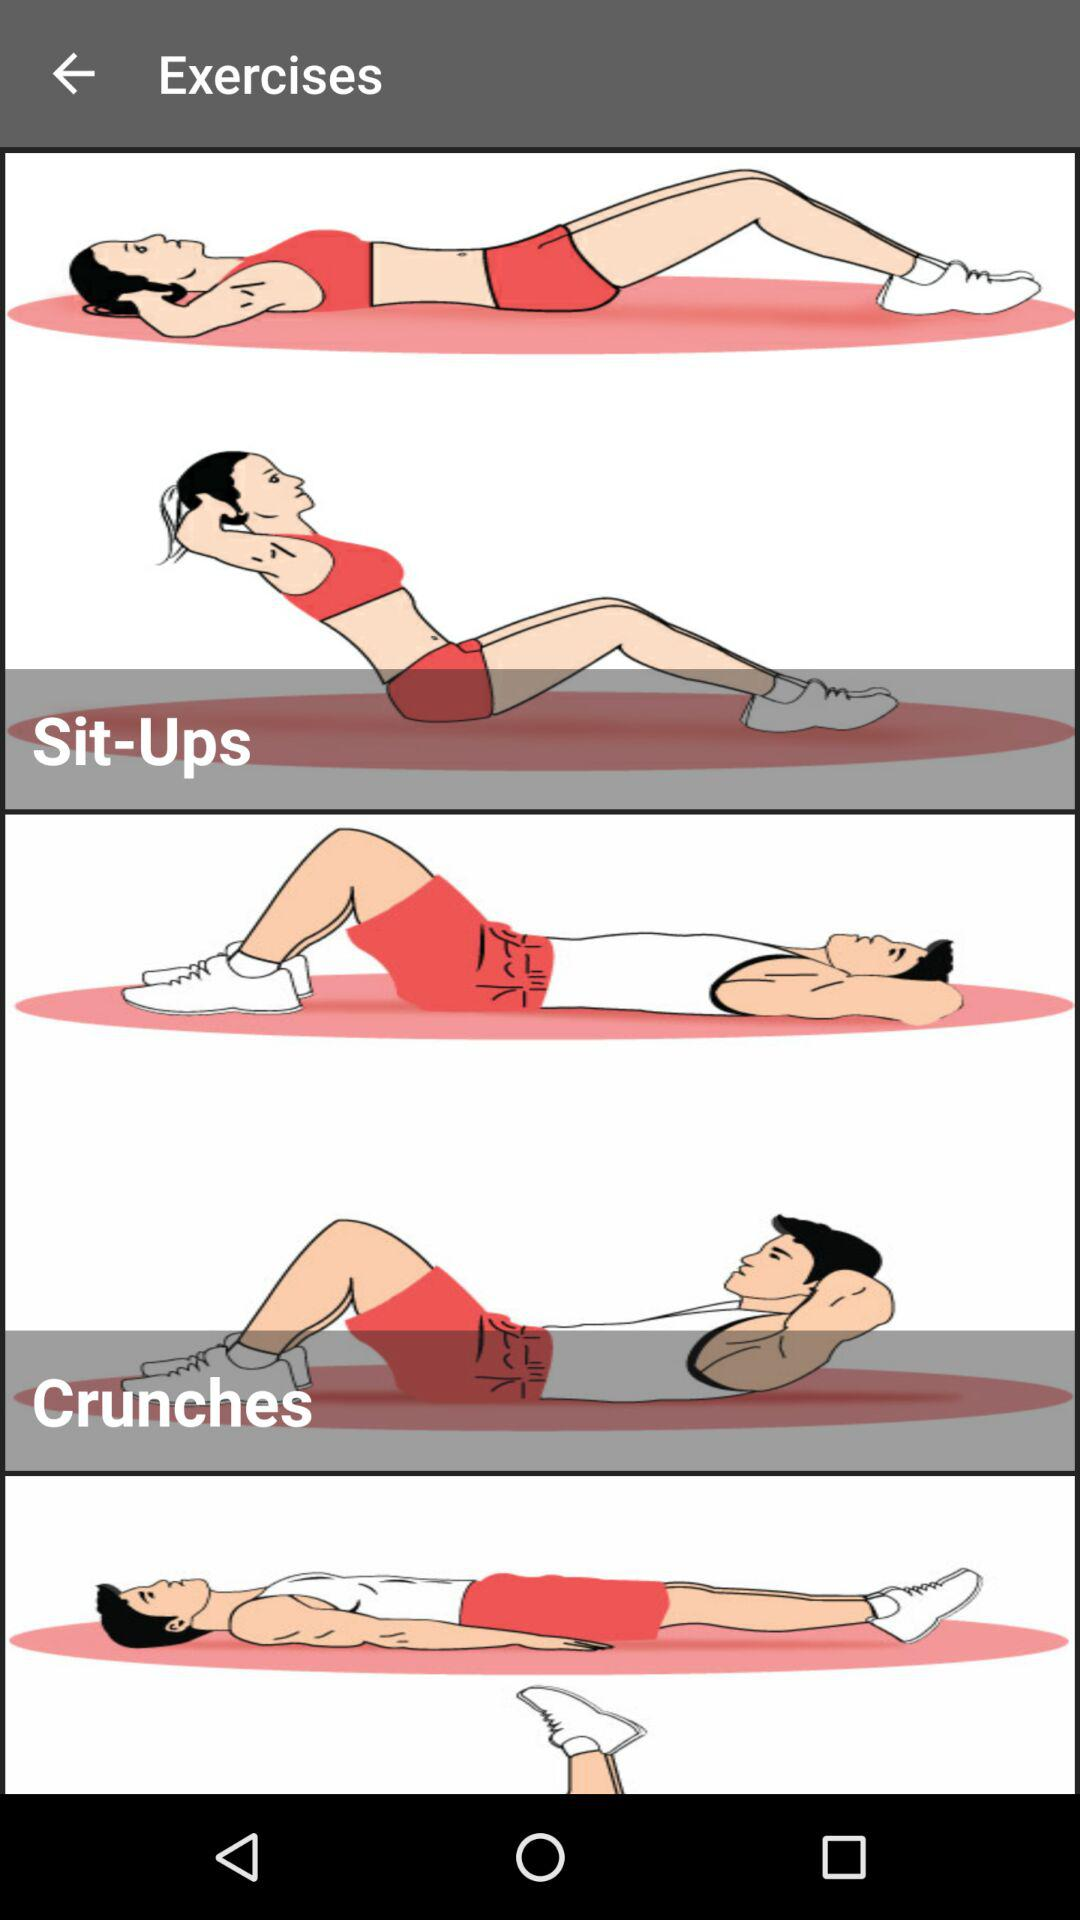How many exercises are there in total?
Answer the question using a single word or phrase. 3 